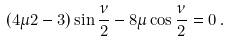<formula> <loc_0><loc_0><loc_500><loc_500>( 4 \mu 2 - 3 ) \sin \frac { \nu } { 2 } - 8 \mu \cos \frac { \nu } { 2 } = 0 \, .</formula> 